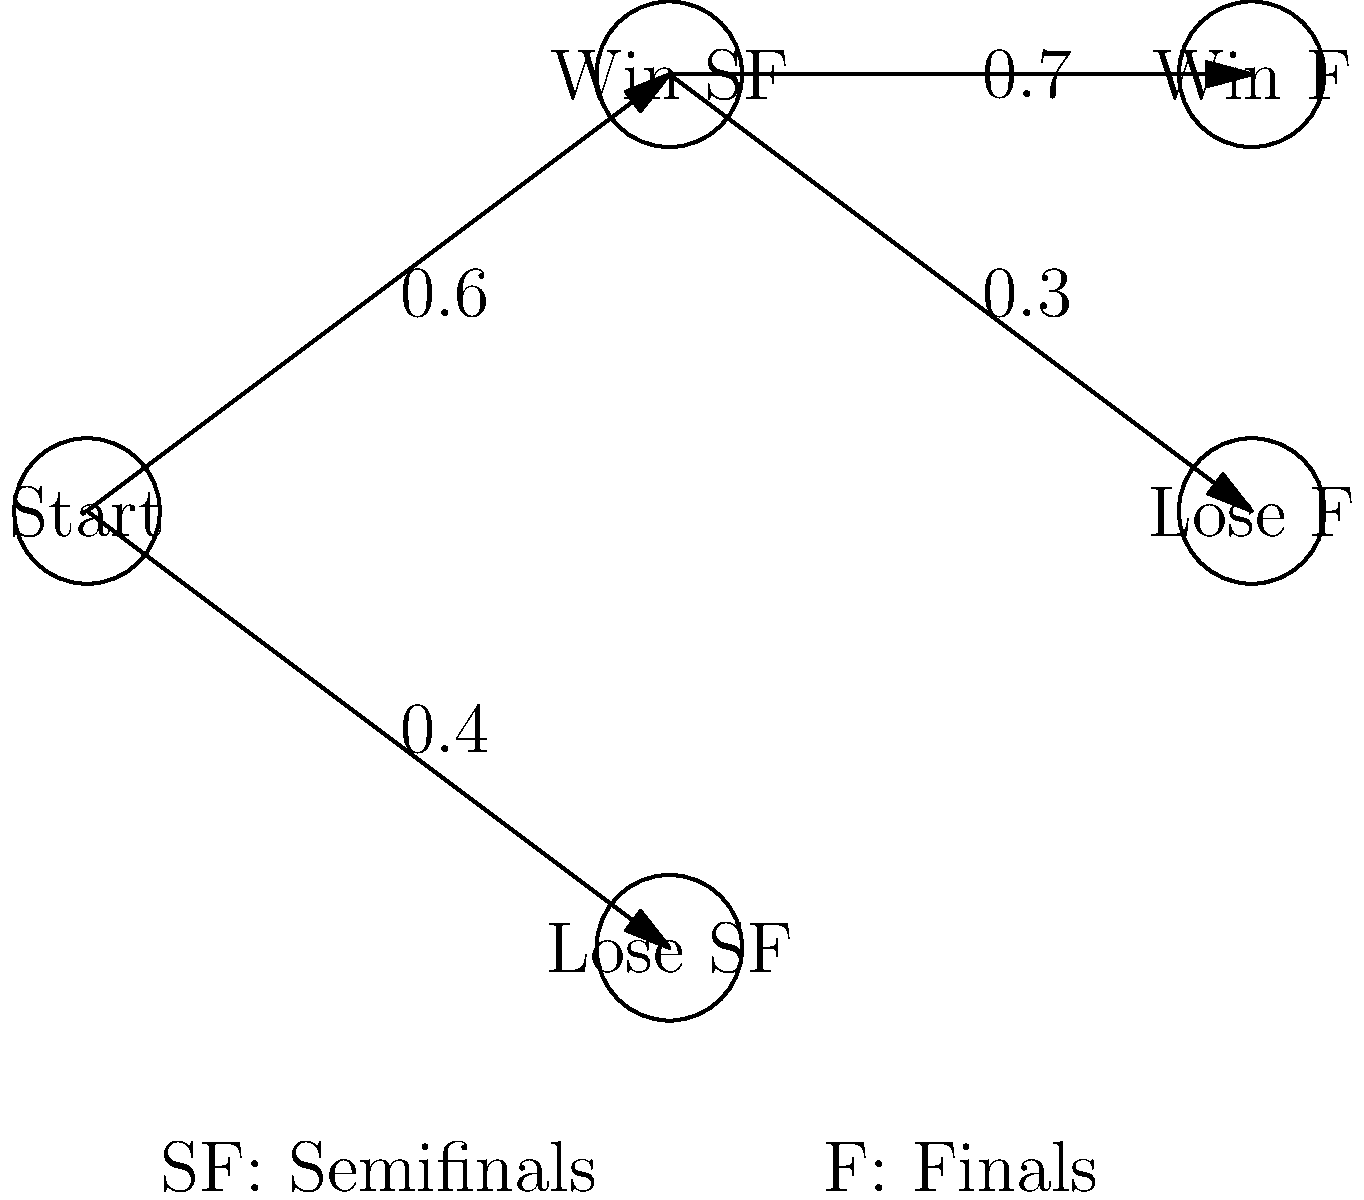In the upcoming PBA playoffs, you're predicting the outcomes for your favorite team. The decision tree shows the probabilities of winning or losing in the semifinals (SF) and finals (F). What is the probability that your team will win both the semifinals and the finals? To find the probability of winning both the semifinals and the finals, we need to follow these steps:

1. Identify the path that represents winning both the semifinals and the finals.
   This path goes from "Start" to "Win SF" to "Win F".

2. Find the probability of winning the semifinals:
   P(Win SF) = 0.6

3. Find the probability of winning the finals, given that the team won the semifinals:
   P(Win F | Win SF) = 0.7

4. Calculate the joint probability of both events occurring:
   P(Win SF and Win F) = P(Win SF) × P(Win F | Win SF)
   
   $P(\text{Win SF and Win F}) = 0.6 \times 0.7 = 0.42$

Therefore, the probability of the team winning both the semifinals and the finals is 0.42 or 42%.
Answer: 0.42 